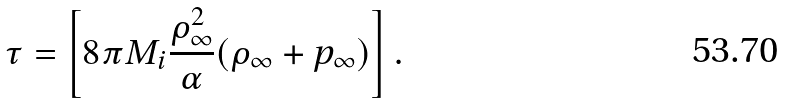Convert formula to latex. <formula><loc_0><loc_0><loc_500><loc_500>\tau = \left [ 8 \pi M _ { i } \frac { \rho _ { \infty } ^ { 2 } } { \alpha } ( \rho _ { \infty } + p _ { \infty } ) \right ] .</formula> 